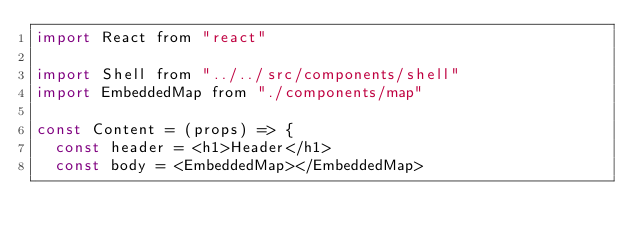<code> <loc_0><loc_0><loc_500><loc_500><_JavaScript_>import React from "react"

import Shell from "../../src/components/shell"
import EmbeddedMap from "./components/map"

const Content = (props) => {
  const header = <h1>Header</h1>
  const body = <EmbeddedMap></EmbeddedMap></code> 